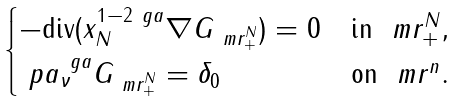<formula> <loc_0><loc_0><loc_500><loc_500>\begin{cases} - \text {div} ( x _ { N } ^ { 1 - 2 \ g a } \nabla G _ { \ m r ^ { N } _ { + } } ) = 0 & \text {in } \ m r ^ { N } _ { + } , \\ \ p a _ { \nu } ^ { \ g a } G _ { \ m r ^ { N } _ { + } } = \delta _ { 0 } & \text {on } \ m r ^ { n } . \end{cases}</formula> 